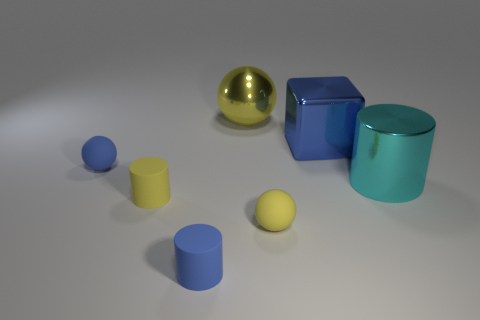Subtract all small yellow rubber spheres. How many spheres are left? 2 Subtract 1 cylinders. How many cylinders are left? 2 Subtract all yellow spheres. How many spheres are left? 1 Add 3 big cubes. How many objects exist? 10 Subtract all blue blocks. How many yellow balls are left? 2 Add 1 small rubber spheres. How many small rubber spheres are left? 3 Add 6 small gray matte cubes. How many small gray matte cubes exist? 6 Subtract 0 red cubes. How many objects are left? 7 Subtract all cylinders. How many objects are left? 4 Subtract all cyan cylinders. Subtract all yellow spheres. How many cylinders are left? 2 